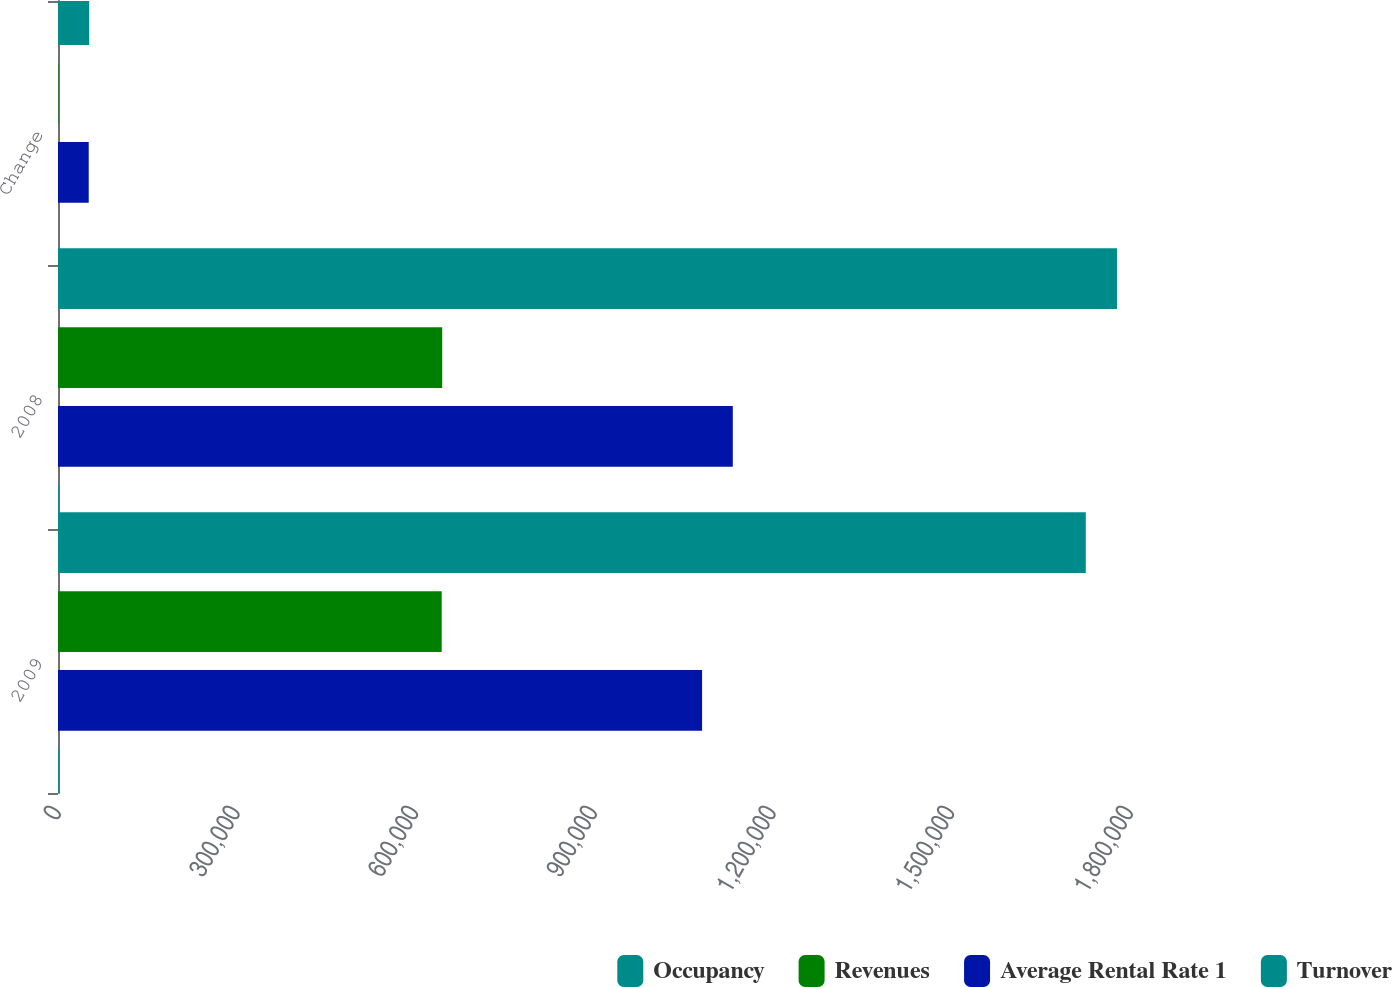Convert chart to OTSL. <chart><loc_0><loc_0><loc_500><loc_500><stacked_bar_chart><ecel><fcel>2009<fcel>2008<fcel>Change<nl><fcel>Occupancy<fcel>1.72577e+06<fcel>1.77818e+06<fcel>52409<nl><fcel>Revenues<fcel>644294<fcel>645123<fcel>829<nl><fcel>Average Rental Rate 1<fcel>1.08148e+06<fcel>1.13306e+06<fcel>51580<nl><fcel>Turnover<fcel>1352<fcel>1383<fcel>31<nl></chart> 